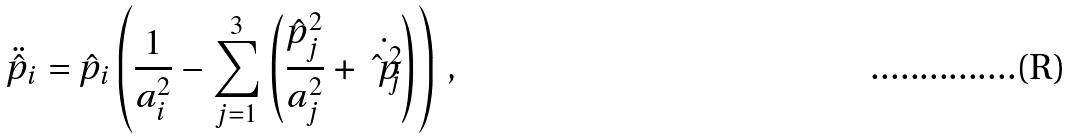Convert formula to latex. <formula><loc_0><loc_0><loc_500><loc_500>\ddot { \hat { p } } _ { i } = \hat { p } _ { i } \left ( \frac { 1 } { a _ { i } ^ { 2 } } - \sum _ { j = 1 } ^ { 3 } \left ( \frac { \hat { p } _ { j } ^ { 2 } } { a _ { j } ^ { 2 } } + \dot { \hat { p } _ { j } ^ { 2 } } \right ) \right ) \, ,</formula> 